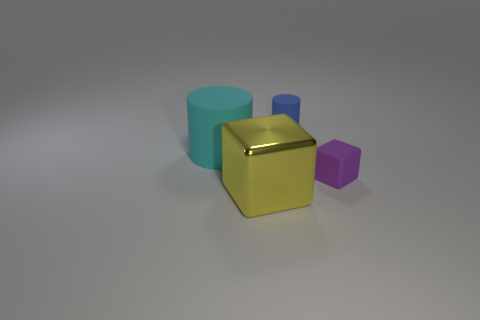Add 1 yellow shiny cylinders. How many objects exist? 5 Add 2 big matte cylinders. How many big matte cylinders exist? 3 Subtract 0 brown cylinders. How many objects are left? 4 Subtract all large cylinders. Subtract all small purple cubes. How many objects are left? 2 Add 2 yellow metallic things. How many yellow metallic things are left? 3 